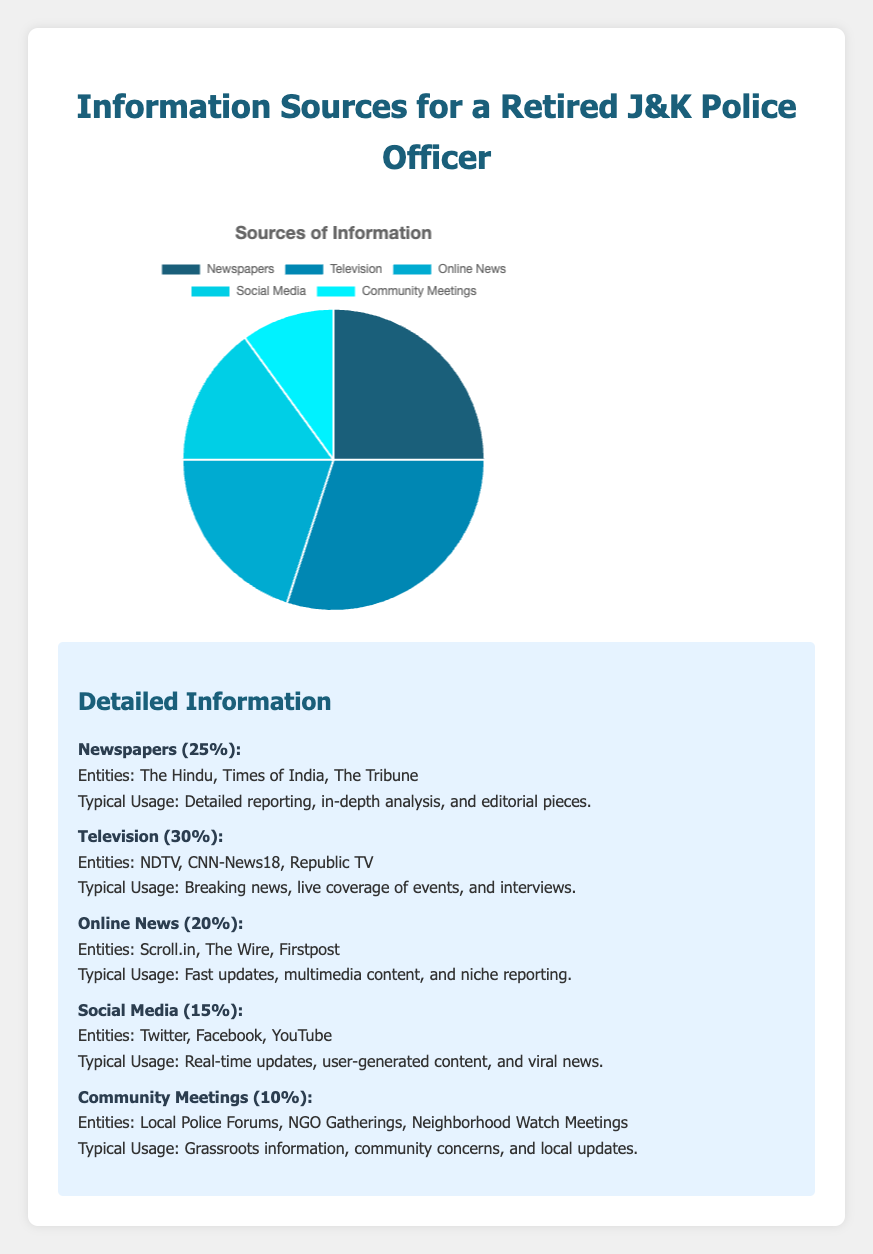What is the most used source of information? The pie chart shows the percentage of each information source. The biggest slice represents Television with 30%.
Answer: Television Which sources of information make up more than 50% of the total? Adding the percentages of the largest sources together: Newspapers (25%) + Television (30%) = 55%, which is more than 50%.
Answer: Newspapers, Television What's the difference in percentage between the most used and least used sources of information? The most used source is Television (30%) and the least used is Community Meetings (10%). Subtracting these gives 30% - 10% = 20%.
Answer: 20% Are Community Meetings used less than Social Media? The pie chart shows Community Meetings at 10% and Social Media at 15%. Since 10% is less than 15%, Community Meetings are used less.
Answer: Yes What percentage of information does Online News and Social Media together provide? Adding the percentages of Online News (20%) and Social Media (15%) gives 20% + 15% = 35%.
Answer: 35% Which sources of information contribute less than 20% each? From the pie chart, Online News (20%), Social Media (15%), and Community Meetings (10%) all contribute less than the 20% threshold.
Answer: Social Media, Community Meetings What is the combined percentage use of Newspapers and Community Meetings? Adding the percentages of Newspapers (25%) and Community Meetings (10%) gives 25% + 10% = 35%.
Answer: 35% Is Online News used more than Newspapers? The chart shows that Online News is at 20% and Newspapers are at 25%. Since 20% is less than 25%, Online News is used less.
Answer: No What's the total percentage contribution of sources other than Television? Adding the percentages of all sources except Television (25% + 20% + 15% + 10%) gives 25% + 20% + 15% + 10% = 70%.
Answer: 70% Which source contributes the smallest percentage? The smallest slice of the pie chart corresponds to Community Meetings, which has a percentage of 10%.
Answer: Community Meetings 